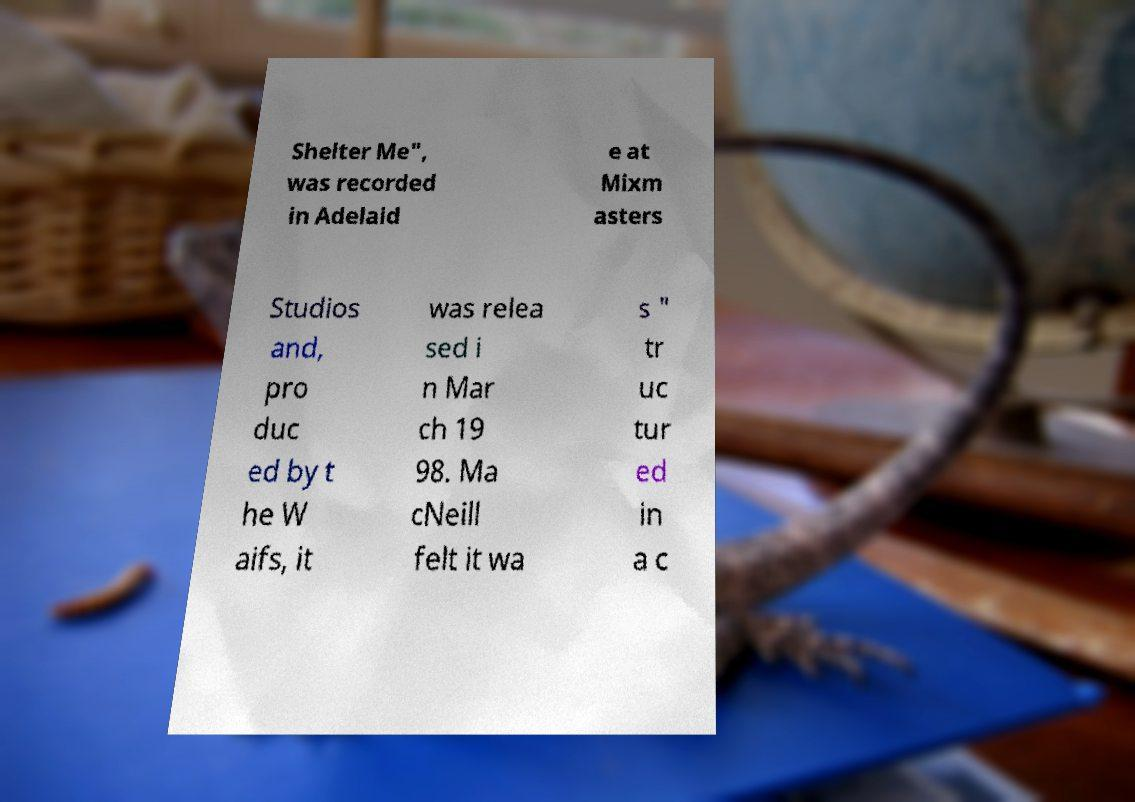Could you assist in decoding the text presented in this image and type it out clearly? Shelter Me", was recorded in Adelaid e at Mixm asters Studios and, pro duc ed by t he W aifs, it was relea sed i n Mar ch 19 98. Ma cNeill felt it wa s " tr uc tur ed in a c 